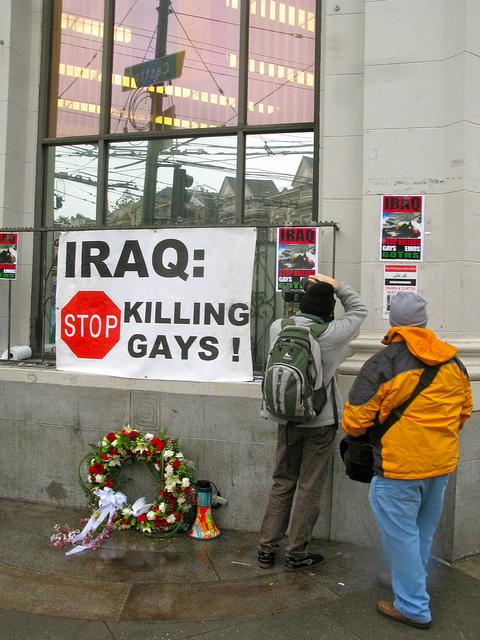What type of death might the Wreath commemorate? Please explain your reasoning. gay person. The sign near the window advocates against killing people with this sexual orientation. 